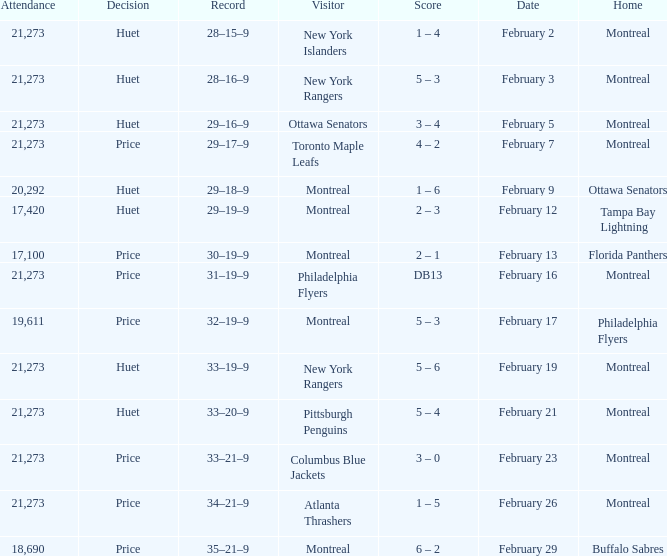What was the date of the game when the Canadiens had a record of 31–19–9? February 16. 